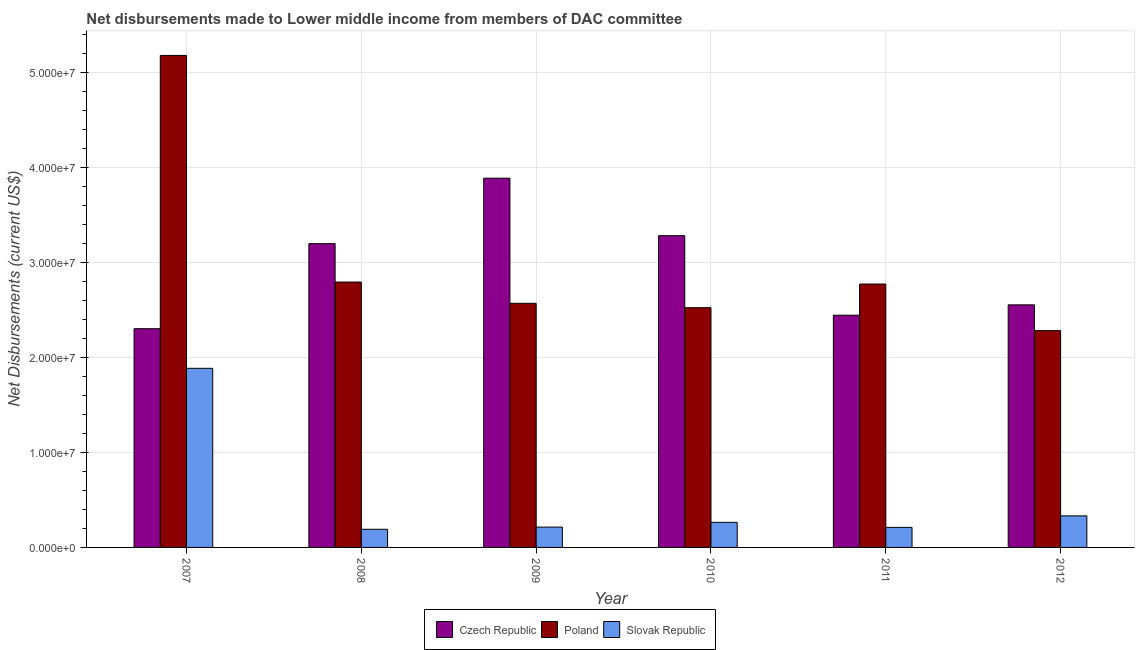How many different coloured bars are there?
Your response must be concise. 3. Are the number of bars per tick equal to the number of legend labels?
Make the answer very short. Yes. Are the number of bars on each tick of the X-axis equal?
Make the answer very short. Yes. What is the label of the 6th group of bars from the left?
Give a very brief answer. 2012. What is the net disbursements made by slovak republic in 2008?
Offer a terse response. 1.91e+06. Across all years, what is the maximum net disbursements made by poland?
Your answer should be compact. 5.18e+07. Across all years, what is the minimum net disbursements made by czech republic?
Your response must be concise. 2.30e+07. In which year was the net disbursements made by czech republic minimum?
Make the answer very short. 2007. What is the total net disbursements made by poland in the graph?
Your response must be concise. 1.81e+08. What is the difference between the net disbursements made by poland in 2008 and that in 2009?
Offer a terse response. 2.24e+06. What is the difference between the net disbursements made by poland in 2007 and the net disbursements made by slovak republic in 2011?
Your answer should be compact. 2.41e+07. What is the average net disbursements made by czech republic per year?
Offer a terse response. 2.94e+07. In how many years, is the net disbursements made by poland greater than 34000000 US$?
Your response must be concise. 1. What is the ratio of the net disbursements made by slovak republic in 2011 to that in 2012?
Provide a short and direct response. 0.64. Is the difference between the net disbursements made by slovak republic in 2011 and 2012 greater than the difference between the net disbursements made by czech republic in 2011 and 2012?
Make the answer very short. No. What is the difference between the highest and the second highest net disbursements made by slovak republic?
Provide a succinct answer. 1.55e+07. What is the difference between the highest and the lowest net disbursements made by czech republic?
Your response must be concise. 1.58e+07. What does the 3rd bar from the left in 2010 represents?
Your answer should be compact. Slovak Republic. What does the 3rd bar from the right in 2011 represents?
Provide a succinct answer. Czech Republic. Is it the case that in every year, the sum of the net disbursements made by czech republic and net disbursements made by poland is greater than the net disbursements made by slovak republic?
Your response must be concise. Yes. What is the difference between two consecutive major ticks on the Y-axis?
Keep it short and to the point. 1.00e+07. Are the values on the major ticks of Y-axis written in scientific E-notation?
Provide a short and direct response. Yes. Does the graph contain any zero values?
Provide a succinct answer. No. Does the graph contain grids?
Give a very brief answer. Yes. Where does the legend appear in the graph?
Your response must be concise. Bottom center. How many legend labels are there?
Your response must be concise. 3. What is the title of the graph?
Your answer should be compact. Net disbursements made to Lower middle income from members of DAC committee. Does "Textiles and clothing" appear as one of the legend labels in the graph?
Your answer should be compact. No. What is the label or title of the Y-axis?
Your response must be concise. Net Disbursements (current US$). What is the Net Disbursements (current US$) of Czech Republic in 2007?
Make the answer very short. 2.30e+07. What is the Net Disbursements (current US$) in Poland in 2007?
Your answer should be compact. 5.18e+07. What is the Net Disbursements (current US$) in Slovak Republic in 2007?
Provide a succinct answer. 1.88e+07. What is the Net Disbursements (current US$) in Czech Republic in 2008?
Ensure brevity in your answer.  3.20e+07. What is the Net Disbursements (current US$) in Poland in 2008?
Your answer should be very brief. 2.79e+07. What is the Net Disbursements (current US$) of Slovak Republic in 2008?
Your answer should be very brief. 1.91e+06. What is the Net Disbursements (current US$) of Czech Republic in 2009?
Keep it short and to the point. 3.89e+07. What is the Net Disbursements (current US$) of Poland in 2009?
Provide a succinct answer. 2.57e+07. What is the Net Disbursements (current US$) in Slovak Republic in 2009?
Provide a succinct answer. 2.14e+06. What is the Net Disbursements (current US$) of Czech Republic in 2010?
Provide a succinct answer. 3.28e+07. What is the Net Disbursements (current US$) of Poland in 2010?
Your response must be concise. 2.52e+07. What is the Net Disbursements (current US$) in Slovak Republic in 2010?
Keep it short and to the point. 2.64e+06. What is the Net Disbursements (current US$) of Czech Republic in 2011?
Provide a succinct answer. 2.44e+07. What is the Net Disbursements (current US$) in Poland in 2011?
Your response must be concise. 2.77e+07. What is the Net Disbursements (current US$) in Slovak Republic in 2011?
Give a very brief answer. 2.11e+06. What is the Net Disbursements (current US$) in Czech Republic in 2012?
Provide a succinct answer. 2.55e+07. What is the Net Disbursements (current US$) in Poland in 2012?
Your answer should be very brief. 2.28e+07. What is the Net Disbursements (current US$) in Slovak Republic in 2012?
Offer a very short reply. 3.32e+06. Across all years, what is the maximum Net Disbursements (current US$) of Czech Republic?
Offer a very short reply. 3.89e+07. Across all years, what is the maximum Net Disbursements (current US$) of Poland?
Your answer should be compact. 5.18e+07. Across all years, what is the maximum Net Disbursements (current US$) in Slovak Republic?
Give a very brief answer. 1.88e+07. Across all years, what is the minimum Net Disbursements (current US$) of Czech Republic?
Ensure brevity in your answer.  2.30e+07. Across all years, what is the minimum Net Disbursements (current US$) of Poland?
Give a very brief answer. 2.28e+07. Across all years, what is the minimum Net Disbursements (current US$) of Slovak Republic?
Your answer should be compact. 1.91e+06. What is the total Net Disbursements (current US$) of Czech Republic in the graph?
Your response must be concise. 1.77e+08. What is the total Net Disbursements (current US$) in Poland in the graph?
Offer a very short reply. 1.81e+08. What is the total Net Disbursements (current US$) of Slovak Republic in the graph?
Your answer should be compact. 3.10e+07. What is the difference between the Net Disbursements (current US$) in Czech Republic in 2007 and that in 2008?
Give a very brief answer. -8.95e+06. What is the difference between the Net Disbursements (current US$) of Poland in 2007 and that in 2008?
Provide a short and direct response. 2.38e+07. What is the difference between the Net Disbursements (current US$) in Slovak Republic in 2007 and that in 2008?
Ensure brevity in your answer.  1.69e+07. What is the difference between the Net Disbursements (current US$) of Czech Republic in 2007 and that in 2009?
Your response must be concise. -1.58e+07. What is the difference between the Net Disbursements (current US$) in Poland in 2007 and that in 2009?
Offer a very short reply. 2.61e+07. What is the difference between the Net Disbursements (current US$) of Slovak Republic in 2007 and that in 2009?
Give a very brief answer. 1.67e+07. What is the difference between the Net Disbursements (current US$) in Czech Republic in 2007 and that in 2010?
Offer a terse response. -9.79e+06. What is the difference between the Net Disbursements (current US$) in Poland in 2007 and that in 2010?
Your answer should be very brief. 2.66e+07. What is the difference between the Net Disbursements (current US$) of Slovak Republic in 2007 and that in 2010?
Provide a short and direct response. 1.62e+07. What is the difference between the Net Disbursements (current US$) in Czech Republic in 2007 and that in 2011?
Your response must be concise. -1.42e+06. What is the difference between the Net Disbursements (current US$) in Poland in 2007 and that in 2011?
Keep it short and to the point. 2.41e+07. What is the difference between the Net Disbursements (current US$) of Slovak Republic in 2007 and that in 2011?
Offer a very short reply. 1.67e+07. What is the difference between the Net Disbursements (current US$) in Czech Republic in 2007 and that in 2012?
Your answer should be compact. -2.51e+06. What is the difference between the Net Disbursements (current US$) of Poland in 2007 and that in 2012?
Your answer should be very brief. 2.90e+07. What is the difference between the Net Disbursements (current US$) in Slovak Republic in 2007 and that in 2012?
Make the answer very short. 1.55e+07. What is the difference between the Net Disbursements (current US$) of Czech Republic in 2008 and that in 2009?
Your answer should be compact. -6.89e+06. What is the difference between the Net Disbursements (current US$) of Poland in 2008 and that in 2009?
Ensure brevity in your answer.  2.24e+06. What is the difference between the Net Disbursements (current US$) in Czech Republic in 2008 and that in 2010?
Ensure brevity in your answer.  -8.40e+05. What is the difference between the Net Disbursements (current US$) in Poland in 2008 and that in 2010?
Your response must be concise. 2.70e+06. What is the difference between the Net Disbursements (current US$) of Slovak Republic in 2008 and that in 2010?
Your answer should be compact. -7.30e+05. What is the difference between the Net Disbursements (current US$) of Czech Republic in 2008 and that in 2011?
Provide a succinct answer. 7.53e+06. What is the difference between the Net Disbursements (current US$) in Czech Republic in 2008 and that in 2012?
Provide a succinct answer. 6.44e+06. What is the difference between the Net Disbursements (current US$) in Poland in 2008 and that in 2012?
Offer a terse response. 5.11e+06. What is the difference between the Net Disbursements (current US$) in Slovak Republic in 2008 and that in 2012?
Provide a succinct answer. -1.41e+06. What is the difference between the Net Disbursements (current US$) in Czech Republic in 2009 and that in 2010?
Provide a succinct answer. 6.05e+06. What is the difference between the Net Disbursements (current US$) in Slovak Republic in 2009 and that in 2010?
Offer a very short reply. -5.00e+05. What is the difference between the Net Disbursements (current US$) in Czech Republic in 2009 and that in 2011?
Your response must be concise. 1.44e+07. What is the difference between the Net Disbursements (current US$) of Poland in 2009 and that in 2011?
Your answer should be very brief. -2.03e+06. What is the difference between the Net Disbursements (current US$) in Czech Republic in 2009 and that in 2012?
Provide a short and direct response. 1.33e+07. What is the difference between the Net Disbursements (current US$) in Poland in 2009 and that in 2012?
Offer a terse response. 2.87e+06. What is the difference between the Net Disbursements (current US$) of Slovak Republic in 2009 and that in 2012?
Your answer should be very brief. -1.18e+06. What is the difference between the Net Disbursements (current US$) of Czech Republic in 2010 and that in 2011?
Offer a very short reply. 8.37e+06. What is the difference between the Net Disbursements (current US$) of Poland in 2010 and that in 2011?
Provide a succinct answer. -2.49e+06. What is the difference between the Net Disbursements (current US$) of Slovak Republic in 2010 and that in 2011?
Give a very brief answer. 5.30e+05. What is the difference between the Net Disbursements (current US$) in Czech Republic in 2010 and that in 2012?
Offer a very short reply. 7.28e+06. What is the difference between the Net Disbursements (current US$) in Poland in 2010 and that in 2012?
Provide a short and direct response. 2.41e+06. What is the difference between the Net Disbursements (current US$) in Slovak Republic in 2010 and that in 2012?
Offer a terse response. -6.80e+05. What is the difference between the Net Disbursements (current US$) of Czech Republic in 2011 and that in 2012?
Your answer should be compact. -1.09e+06. What is the difference between the Net Disbursements (current US$) in Poland in 2011 and that in 2012?
Offer a very short reply. 4.90e+06. What is the difference between the Net Disbursements (current US$) in Slovak Republic in 2011 and that in 2012?
Give a very brief answer. -1.21e+06. What is the difference between the Net Disbursements (current US$) of Czech Republic in 2007 and the Net Disbursements (current US$) of Poland in 2008?
Provide a succinct answer. -4.91e+06. What is the difference between the Net Disbursements (current US$) in Czech Republic in 2007 and the Net Disbursements (current US$) in Slovak Republic in 2008?
Your answer should be very brief. 2.11e+07. What is the difference between the Net Disbursements (current US$) in Poland in 2007 and the Net Disbursements (current US$) in Slovak Republic in 2008?
Keep it short and to the point. 4.99e+07. What is the difference between the Net Disbursements (current US$) of Czech Republic in 2007 and the Net Disbursements (current US$) of Poland in 2009?
Your response must be concise. -2.67e+06. What is the difference between the Net Disbursements (current US$) in Czech Republic in 2007 and the Net Disbursements (current US$) in Slovak Republic in 2009?
Ensure brevity in your answer.  2.09e+07. What is the difference between the Net Disbursements (current US$) in Poland in 2007 and the Net Disbursements (current US$) in Slovak Republic in 2009?
Give a very brief answer. 4.96e+07. What is the difference between the Net Disbursements (current US$) in Czech Republic in 2007 and the Net Disbursements (current US$) in Poland in 2010?
Your response must be concise. -2.21e+06. What is the difference between the Net Disbursements (current US$) in Czech Republic in 2007 and the Net Disbursements (current US$) in Slovak Republic in 2010?
Offer a very short reply. 2.04e+07. What is the difference between the Net Disbursements (current US$) of Poland in 2007 and the Net Disbursements (current US$) of Slovak Republic in 2010?
Your answer should be very brief. 4.91e+07. What is the difference between the Net Disbursements (current US$) of Czech Republic in 2007 and the Net Disbursements (current US$) of Poland in 2011?
Your answer should be compact. -4.70e+06. What is the difference between the Net Disbursements (current US$) of Czech Republic in 2007 and the Net Disbursements (current US$) of Slovak Republic in 2011?
Offer a very short reply. 2.09e+07. What is the difference between the Net Disbursements (current US$) of Poland in 2007 and the Net Disbursements (current US$) of Slovak Republic in 2011?
Give a very brief answer. 4.97e+07. What is the difference between the Net Disbursements (current US$) in Czech Republic in 2007 and the Net Disbursements (current US$) in Slovak Republic in 2012?
Make the answer very short. 1.97e+07. What is the difference between the Net Disbursements (current US$) of Poland in 2007 and the Net Disbursements (current US$) of Slovak Republic in 2012?
Give a very brief answer. 4.85e+07. What is the difference between the Net Disbursements (current US$) of Czech Republic in 2008 and the Net Disbursements (current US$) of Poland in 2009?
Keep it short and to the point. 6.28e+06. What is the difference between the Net Disbursements (current US$) in Czech Republic in 2008 and the Net Disbursements (current US$) in Slovak Republic in 2009?
Keep it short and to the point. 2.98e+07. What is the difference between the Net Disbursements (current US$) in Poland in 2008 and the Net Disbursements (current US$) in Slovak Republic in 2009?
Provide a short and direct response. 2.58e+07. What is the difference between the Net Disbursements (current US$) of Czech Republic in 2008 and the Net Disbursements (current US$) of Poland in 2010?
Keep it short and to the point. 6.74e+06. What is the difference between the Net Disbursements (current US$) of Czech Republic in 2008 and the Net Disbursements (current US$) of Slovak Republic in 2010?
Keep it short and to the point. 2.93e+07. What is the difference between the Net Disbursements (current US$) in Poland in 2008 and the Net Disbursements (current US$) in Slovak Republic in 2010?
Your answer should be compact. 2.53e+07. What is the difference between the Net Disbursements (current US$) in Czech Republic in 2008 and the Net Disbursements (current US$) in Poland in 2011?
Your answer should be very brief. 4.25e+06. What is the difference between the Net Disbursements (current US$) in Czech Republic in 2008 and the Net Disbursements (current US$) in Slovak Republic in 2011?
Your answer should be compact. 2.99e+07. What is the difference between the Net Disbursements (current US$) in Poland in 2008 and the Net Disbursements (current US$) in Slovak Republic in 2011?
Provide a succinct answer. 2.58e+07. What is the difference between the Net Disbursements (current US$) of Czech Republic in 2008 and the Net Disbursements (current US$) of Poland in 2012?
Make the answer very short. 9.15e+06. What is the difference between the Net Disbursements (current US$) of Czech Republic in 2008 and the Net Disbursements (current US$) of Slovak Republic in 2012?
Offer a very short reply. 2.86e+07. What is the difference between the Net Disbursements (current US$) of Poland in 2008 and the Net Disbursements (current US$) of Slovak Republic in 2012?
Your response must be concise. 2.46e+07. What is the difference between the Net Disbursements (current US$) in Czech Republic in 2009 and the Net Disbursements (current US$) in Poland in 2010?
Your response must be concise. 1.36e+07. What is the difference between the Net Disbursements (current US$) in Czech Republic in 2009 and the Net Disbursements (current US$) in Slovak Republic in 2010?
Keep it short and to the point. 3.62e+07. What is the difference between the Net Disbursements (current US$) in Poland in 2009 and the Net Disbursements (current US$) in Slovak Republic in 2010?
Provide a short and direct response. 2.30e+07. What is the difference between the Net Disbursements (current US$) of Czech Republic in 2009 and the Net Disbursements (current US$) of Poland in 2011?
Your answer should be very brief. 1.11e+07. What is the difference between the Net Disbursements (current US$) of Czech Republic in 2009 and the Net Disbursements (current US$) of Slovak Republic in 2011?
Offer a terse response. 3.68e+07. What is the difference between the Net Disbursements (current US$) of Poland in 2009 and the Net Disbursements (current US$) of Slovak Republic in 2011?
Make the answer very short. 2.36e+07. What is the difference between the Net Disbursements (current US$) of Czech Republic in 2009 and the Net Disbursements (current US$) of Poland in 2012?
Your response must be concise. 1.60e+07. What is the difference between the Net Disbursements (current US$) in Czech Republic in 2009 and the Net Disbursements (current US$) in Slovak Republic in 2012?
Your response must be concise. 3.55e+07. What is the difference between the Net Disbursements (current US$) in Poland in 2009 and the Net Disbursements (current US$) in Slovak Republic in 2012?
Offer a terse response. 2.24e+07. What is the difference between the Net Disbursements (current US$) in Czech Republic in 2010 and the Net Disbursements (current US$) in Poland in 2011?
Keep it short and to the point. 5.09e+06. What is the difference between the Net Disbursements (current US$) of Czech Republic in 2010 and the Net Disbursements (current US$) of Slovak Republic in 2011?
Ensure brevity in your answer.  3.07e+07. What is the difference between the Net Disbursements (current US$) in Poland in 2010 and the Net Disbursements (current US$) in Slovak Republic in 2011?
Offer a very short reply. 2.31e+07. What is the difference between the Net Disbursements (current US$) in Czech Republic in 2010 and the Net Disbursements (current US$) in Poland in 2012?
Ensure brevity in your answer.  9.99e+06. What is the difference between the Net Disbursements (current US$) of Czech Republic in 2010 and the Net Disbursements (current US$) of Slovak Republic in 2012?
Ensure brevity in your answer.  2.95e+07. What is the difference between the Net Disbursements (current US$) of Poland in 2010 and the Net Disbursements (current US$) of Slovak Republic in 2012?
Your answer should be very brief. 2.19e+07. What is the difference between the Net Disbursements (current US$) of Czech Republic in 2011 and the Net Disbursements (current US$) of Poland in 2012?
Your response must be concise. 1.62e+06. What is the difference between the Net Disbursements (current US$) of Czech Republic in 2011 and the Net Disbursements (current US$) of Slovak Republic in 2012?
Your answer should be compact. 2.11e+07. What is the difference between the Net Disbursements (current US$) in Poland in 2011 and the Net Disbursements (current US$) in Slovak Republic in 2012?
Provide a short and direct response. 2.44e+07. What is the average Net Disbursements (current US$) of Czech Republic per year?
Your response must be concise. 2.94e+07. What is the average Net Disbursements (current US$) of Poland per year?
Keep it short and to the point. 3.02e+07. What is the average Net Disbursements (current US$) of Slovak Republic per year?
Give a very brief answer. 5.16e+06. In the year 2007, what is the difference between the Net Disbursements (current US$) in Czech Republic and Net Disbursements (current US$) in Poland?
Your answer should be very brief. -2.88e+07. In the year 2007, what is the difference between the Net Disbursements (current US$) of Czech Republic and Net Disbursements (current US$) of Slovak Republic?
Your answer should be very brief. 4.17e+06. In the year 2007, what is the difference between the Net Disbursements (current US$) in Poland and Net Disbursements (current US$) in Slovak Republic?
Keep it short and to the point. 3.29e+07. In the year 2008, what is the difference between the Net Disbursements (current US$) in Czech Republic and Net Disbursements (current US$) in Poland?
Give a very brief answer. 4.04e+06. In the year 2008, what is the difference between the Net Disbursements (current US$) of Czech Republic and Net Disbursements (current US$) of Slovak Republic?
Offer a very short reply. 3.01e+07. In the year 2008, what is the difference between the Net Disbursements (current US$) in Poland and Net Disbursements (current US$) in Slovak Republic?
Offer a terse response. 2.60e+07. In the year 2009, what is the difference between the Net Disbursements (current US$) of Czech Republic and Net Disbursements (current US$) of Poland?
Provide a succinct answer. 1.32e+07. In the year 2009, what is the difference between the Net Disbursements (current US$) of Czech Republic and Net Disbursements (current US$) of Slovak Republic?
Provide a short and direct response. 3.67e+07. In the year 2009, what is the difference between the Net Disbursements (current US$) in Poland and Net Disbursements (current US$) in Slovak Republic?
Your answer should be very brief. 2.36e+07. In the year 2010, what is the difference between the Net Disbursements (current US$) in Czech Republic and Net Disbursements (current US$) in Poland?
Keep it short and to the point. 7.58e+06. In the year 2010, what is the difference between the Net Disbursements (current US$) in Czech Republic and Net Disbursements (current US$) in Slovak Republic?
Provide a short and direct response. 3.02e+07. In the year 2010, what is the difference between the Net Disbursements (current US$) of Poland and Net Disbursements (current US$) of Slovak Republic?
Ensure brevity in your answer.  2.26e+07. In the year 2011, what is the difference between the Net Disbursements (current US$) of Czech Republic and Net Disbursements (current US$) of Poland?
Provide a succinct answer. -3.28e+06. In the year 2011, what is the difference between the Net Disbursements (current US$) in Czech Republic and Net Disbursements (current US$) in Slovak Republic?
Make the answer very short. 2.23e+07. In the year 2011, what is the difference between the Net Disbursements (current US$) in Poland and Net Disbursements (current US$) in Slovak Republic?
Your answer should be compact. 2.56e+07. In the year 2012, what is the difference between the Net Disbursements (current US$) of Czech Republic and Net Disbursements (current US$) of Poland?
Your answer should be very brief. 2.71e+06. In the year 2012, what is the difference between the Net Disbursements (current US$) of Czech Republic and Net Disbursements (current US$) of Slovak Republic?
Provide a short and direct response. 2.22e+07. In the year 2012, what is the difference between the Net Disbursements (current US$) of Poland and Net Disbursements (current US$) of Slovak Republic?
Provide a short and direct response. 1.95e+07. What is the ratio of the Net Disbursements (current US$) in Czech Republic in 2007 to that in 2008?
Ensure brevity in your answer.  0.72. What is the ratio of the Net Disbursements (current US$) in Poland in 2007 to that in 2008?
Your answer should be compact. 1.85. What is the ratio of the Net Disbursements (current US$) in Slovak Republic in 2007 to that in 2008?
Your response must be concise. 9.87. What is the ratio of the Net Disbursements (current US$) in Czech Republic in 2007 to that in 2009?
Provide a short and direct response. 0.59. What is the ratio of the Net Disbursements (current US$) of Poland in 2007 to that in 2009?
Provide a succinct answer. 2.02. What is the ratio of the Net Disbursements (current US$) in Slovak Republic in 2007 to that in 2009?
Keep it short and to the point. 8.81. What is the ratio of the Net Disbursements (current US$) of Czech Republic in 2007 to that in 2010?
Provide a short and direct response. 0.7. What is the ratio of the Net Disbursements (current US$) in Poland in 2007 to that in 2010?
Offer a very short reply. 2.05. What is the ratio of the Net Disbursements (current US$) of Slovak Republic in 2007 to that in 2010?
Provide a short and direct response. 7.14. What is the ratio of the Net Disbursements (current US$) in Czech Republic in 2007 to that in 2011?
Keep it short and to the point. 0.94. What is the ratio of the Net Disbursements (current US$) in Poland in 2007 to that in 2011?
Your answer should be compact. 1.87. What is the ratio of the Net Disbursements (current US$) of Slovak Republic in 2007 to that in 2011?
Offer a very short reply. 8.93. What is the ratio of the Net Disbursements (current US$) of Czech Republic in 2007 to that in 2012?
Provide a short and direct response. 0.9. What is the ratio of the Net Disbursements (current US$) of Poland in 2007 to that in 2012?
Your response must be concise. 2.27. What is the ratio of the Net Disbursements (current US$) in Slovak Republic in 2007 to that in 2012?
Your answer should be very brief. 5.68. What is the ratio of the Net Disbursements (current US$) in Czech Republic in 2008 to that in 2009?
Ensure brevity in your answer.  0.82. What is the ratio of the Net Disbursements (current US$) of Poland in 2008 to that in 2009?
Provide a succinct answer. 1.09. What is the ratio of the Net Disbursements (current US$) in Slovak Republic in 2008 to that in 2009?
Provide a succinct answer. 0.89. What is the ratio of the Net Disbursements (current US$) of Czech Republic in 2008 to that in 2010?
Your answer should be compact. 0.97. What is the ratio of the Net Disbursements (current US$) of Poland in 2008 to that in 2010?
Make the answer very short. 1.11. What is the ratio of the Net Disbursements (current US$) in Slovak Republic in 2008 to that in 2010?
Provide a succinct answer. 0.72. What is the ratio of the Net Disbursements (current US$) in Czech Republic in 2008 to that in 2011?
Your answer should be compact. 1.31. What is the ratio of the Net Disbursements (current US$) in Poland in 2008 to that in 2011?
Offer a very short reply. 1.01. What is the ratio of the Net Disbursements (current US$) in Slovak Republic in 2008 to that in 2011?
Your answer should be very brief. 0.91. What is the ratio of the Net Disbursements (current US$) in Czech Republic in 2008 to that in 2012?
Your response must be concise. 1.25. What is the ratio of the Net Disbursements (current US$) of Poland in 2008 to that in 2012?
Keep it short and to the point. 1.22. What is the ratio of the Net Disbursements (current US$) in Slovak Republic in 2008 to that in 2012?
Your answer should be compact. 0.58. What is the ratio of the Net Disbursements (current US$) of Czech Republic in 2009 to that in 2010?
Make the answer very short. 1.18. What is the ratio of the Net Disbursements (current US$) in Poland in 2009 to that in 2010?
Offer a very short reply. 1.02. What is the ratio of the Net Disbursements (current US$) of Slovak Republic in 2009 to that in 2010?
Keep it short and to the point. 0.81. What is the ratio of the Net Disbursements (current US$) of Czech Republic in 2009 to that in 2011?
Ensure brevity in your answer.  1.59. What is the ratio of the Net Disbursements (current US$) in Poland in 2009 to that in 2011?
Your answer should be compact. 0.93. What is the ratio of the Net Disbursements (current US$) in Slovak Republic in 2009 to that in 2011?
Ensure brevity in your answer.  1.01. What is the ratio of the Net Disbursements (current US$) of Czech Republic in 2009 to that in 2012?
Make the answer very short. 1.52. What is the ratio of the Net Disbursements (current US$) in Poland in 2009 to that in 2012?
Provide a succinct answer. 1.13. What is the ratio of the Net Disbursements (current US$) of Slovak Republic in 2009 to that in 2012?
Make the answer very short. 0.64. What is the ratio of the Net Disbursements (current US$) in Czech Republic in 2010 to that in 2011?
Offer a very short reply. 1.34. What is the ratio of the Net Disbursements (current US$) of Poland in 2010 to that in 2011?
Offer a very short reply. 0.91. What is the ratio of the Net Disbursements (current US$) in Slovak Republic in 2010 to that in 2011?
Keep it short and to the point. 1.25. What is the ratio of the Net Disbursements (current US$) of Czech Republic in 2010 to that in 2012?
Offer a very short reply. 1.29. What is the ratio of the Net Disbursements (current US$) of Poland in 2010 to that in 2012?
Provide a succinct answer. 1.11. What is the ratio of the Net Disbursements (current US$) in Slovak Republic in 2010 to that in 2012?
Make the answer very short. 0.8. What is the ratio of the Net Disbursements (current US$) of Czech Republic in 2011 to that in 2012?
Make the answer very short. 0.96. What is the ratio of the Net Disbursements (current US$) in Poland in 2011 to that in 2012?
Ensure brevity in your answer.  1.21. What is the ratio of the Net Disbursements (current US$) of Slovak Republic in 2011 to that in 2012?
Provide a short and direct response. 0.64. What is the difference between the highest and the second highest Net Disbursements (current US$) in Czech Republic?
Provide a succinct answer. 6.05e+06. What is the difference between the highest and the second highest Net Disbursements (current US$) in Poland?
Offer a terse response. 2.38e+07. What is the difference between the highest and the second highest Net Disbursements (current US$) in Slovak Republic?
Offer a terse response. 1.55e+07. What is the difference between the highest and the lowest Net Disbursements (current US$) in Czech Republic?
Provide a succinct answer. 1.58e+07. What is the difference between the highest and the lowest Net Disbursements (current US$) in Poland?
Your answer should be compact. 2.90e+07. What is the difference between the highest and the lowest Net Disbursements (current US$) in Slovak Republic?
Your answer should be very brief. 1.69e+07. 